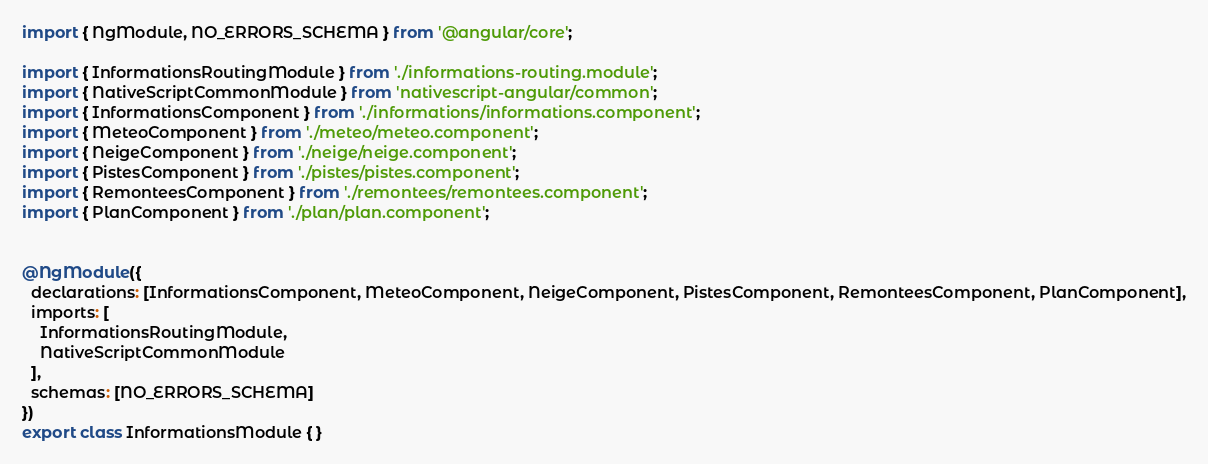<code> <loc_0><loc_0><loc_500><loc_500><_TypeScript_>import { NgModule, NO_ERRORS_SCHEMA } from '@angular/core';

import { InformationsRoutingModule } from './informations-routing.module';
import { NativeScriptCommonModule } from 'nativescript-angular/common';
import { InformationsComponent } from './informations/informations.component';
import { MeteoComponent } from './meteo/meteo.component';
import { NeigeComponent } from './neige/neige.component';
import { PistesComponent } from './pistes/pistes.component';
import { RemonteesComponent } from './remontees/remontees.component';
import { PlanComponent } from './plan/plan.component';


@NgModule({
  declarations: [InformationsComponent, MeteoComponent, NeigeComponent, PistesComponent, RemonteesComponent, PlanComponent],
  imports: [
    InformationsRoutingModule,
    NativeScriptCommonModule
  ],
  schemas: [NO_ERRORS_SCHEMA]
})
export class InformationsModule { }
</code> 